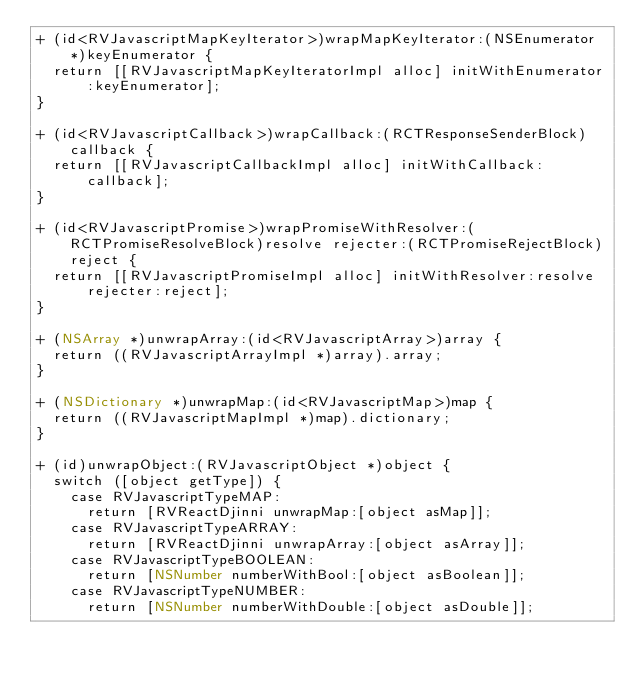<code> <loc_0><loc_0><loc_500><loc_500><_ObjectiveC_>+ (id<RVJavascriptMapKeyIterator>)wrapMapKeyIterator:(NSEnumerator *)keyEnumerator {
  return [[RVJavascriptMapKeyIteratorImpl alloc] initWithEnumerator:keyEnumerator];
}

+ (id<RVJavascriptCallback>)wrapCallback:(RCTResponseSenderBlock)callback {
  return [[RVJavascriptCallbackImpl alloc] initWithCallback:callback];
}

+ (id<RVJavascriptPromise>)wrapPromiseWithResolver:(RCTPromiseResolveBlock)resolve rejecter:(RCTPromiseRejectBlock)reject {
  return [[RVJavascriptPromiseImpl alloc] initWithResolver:resolve rejecter:reject];
}

+ (NSArray *)unwrapArray:(id<RVJavascriptArray>)array {
  return ((RVJavascriptArrayImpl *)array).array;
}

+ (NSDictionary *)unwrapMap:(id<RVJavascriptMap>)map {
  return ((RVJavascriptMapImpl *)map).dictionary;
}

+ (id)unwrapObject:(RVJavascriptObject *)object {
  switch ([object getType]) {
    case RVJavascriptTypeMAP:
      return [RVReactDjinni unwrapMap:[object asMap]];
    case RVJavascriptTypeARRAY:
      return [RVReactDjinni unwrapArray:[object asArray]];
    case RVJavascriptTypeBOOLEAN:
      return [NSNumber numberWithBool:[object asBoolean]];
    case RVJavascriptTypeNUMBER:
      return [NSNumber numberWithDouble:[object asDouble]];</code> 